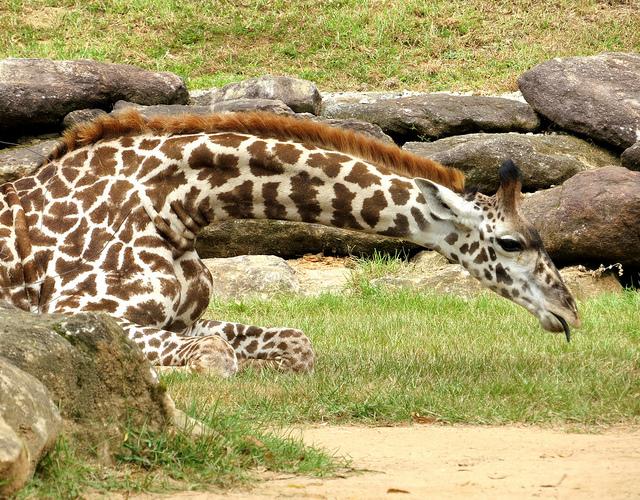Are there rocks in the image?
Concise answer only. Yes. Does this animal have a long neck?
Concise answer only. Yes. Is there any giraffe are there?
Be succinct. Yes. 